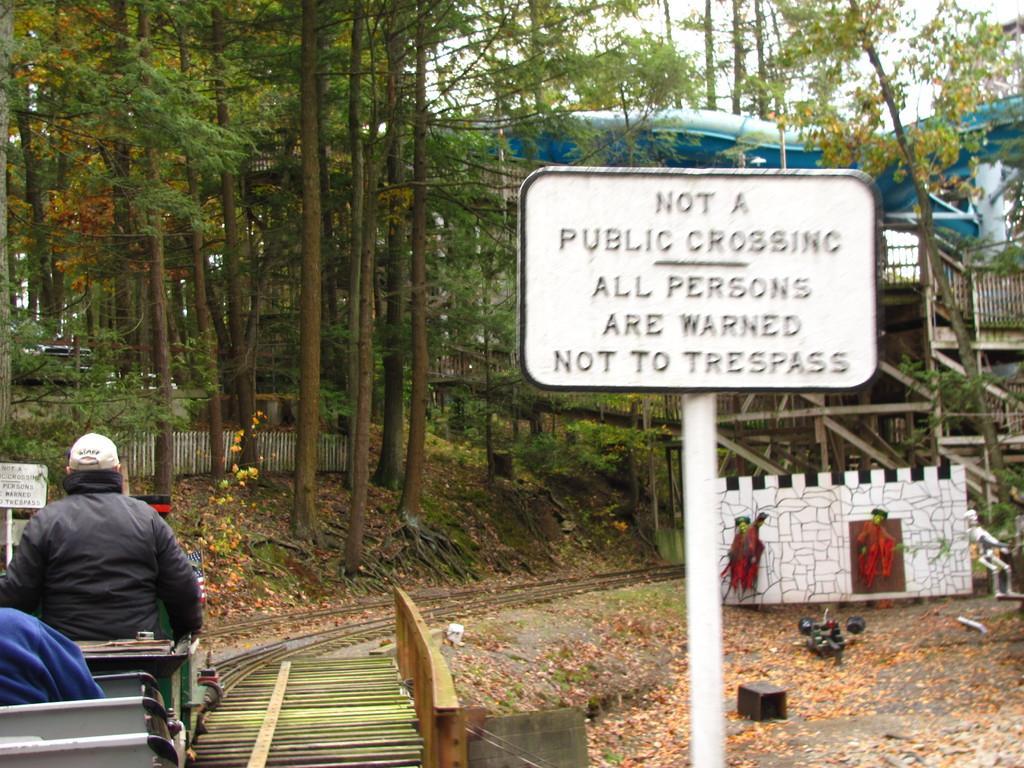Could you give a brief overview of what you see in this image? In this image, we can see a white color sign board and at the left side there is a man sitting, in the background there are some green trees. 